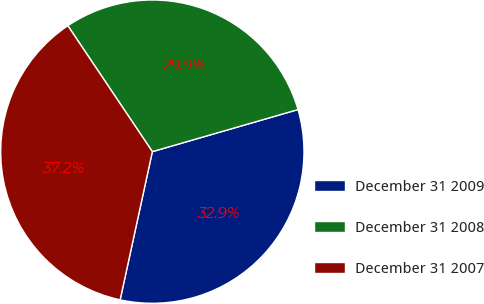Convert chart to OTSL. <chart><loc_0><loc_0><loc_500><loc_500><pie_chart><fcel>December 31 2009<fcel>December 31 2008<fcel>December 31 2007<nl><fcel>32.88%<fcel>29.93%<fcel>37.18%<nl></chart> 